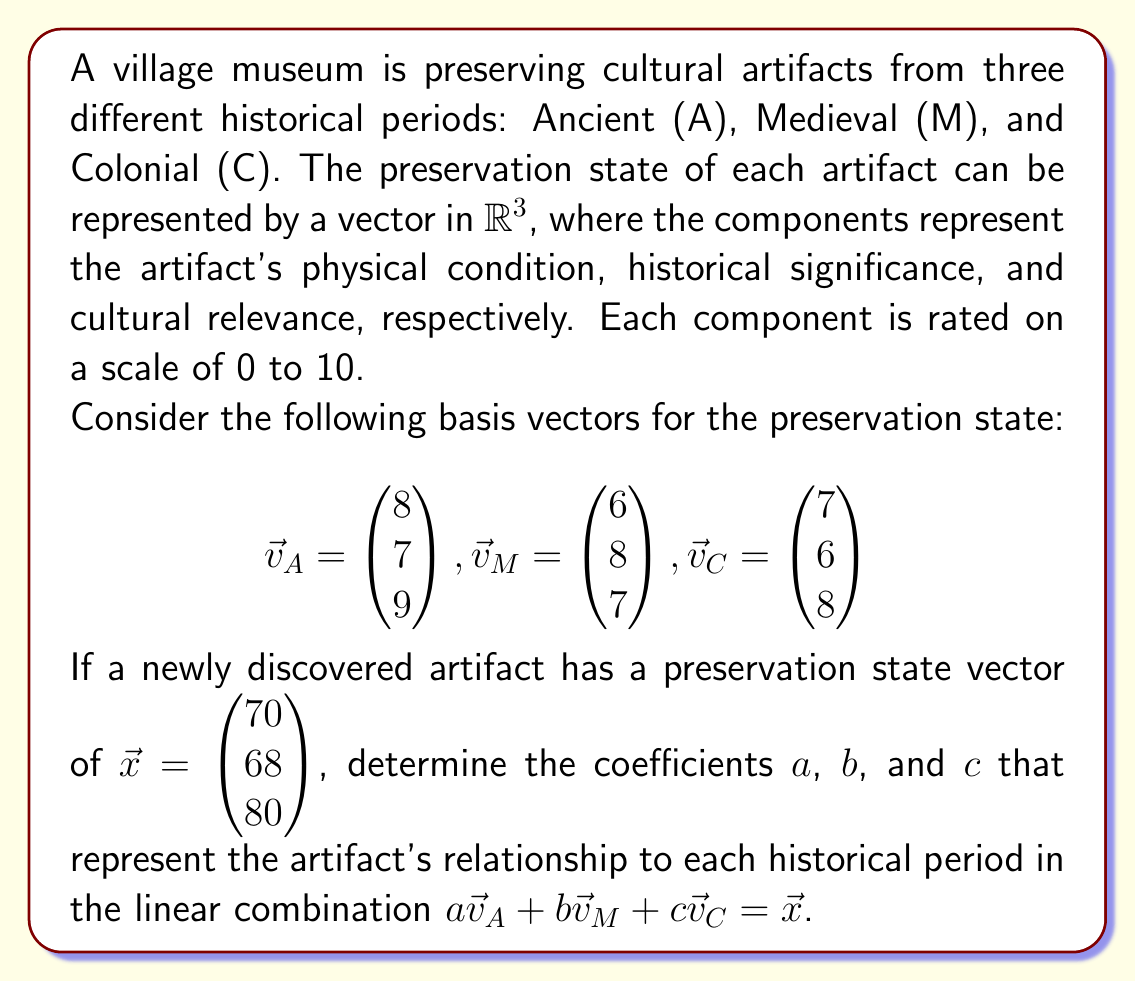Can you answer this question? To solve this problem, we need to use the concept of linear combinations and solving systems of linear equations. Let's approach this step-by-step:

1) We are given that $a\vec{v}_A + b\vec{v}_M + c\vec{v}_C = \vec{x}$. Let's expand this equation:

   $$ a\begin{pmatrix} 8 \\ 7 \\ 9 \end{pmatrix} + b\begin{pmatrix} 6 \\ 8 \\ 7 \end{pmatrix} + c\begin{pmatrix} 7 \\ 6 \\ 8 \end{pmatrix} = \begin{pmatrix} 70 \\ 68 \\ 80 \end{pmatrix} $$

2) This gives us a system of three linear equations:

   $$ 8a + 6b + 7c = 70 $$
   $$ 7a + 8b + 6c = 68 $$
   $$ 9a + 7b + 8c = 80 $$

3) We can solve this system using various methods. Let's use the elimination method:

4) Multiply the first equation by 7 and the second by -8:

   $$ 56a + 42b + 49c = 490 $$
   $$ -56a - 64b - 48c = -544 $$

5) Add these equations:

   $$ -22b + c = -54 $$

6) Multiply the second equation by 9 and the third by -7:

   $$ 63a + 72b + 54c = 612 $$
   $$ -63a - 49b - 56c = -560 $$

7) Add these equations:

   $$ 23b - 2c = 52 $$

8) Now we have two equations with two unknowns:

   $$ -22b + c = -54 $$
   $$ 23b - 2c = 52 $$

9) Multiply the first equation by 2 and add to the second:

   $$ -21b = -56 $$
   $$ b = \frac{56}{21} = \frac{8}{3} $$

10) Substitute this value of $b$ back into $-22b + c = -54$:

    $$ -22(\frac{8}{3}) + c = -54 $$
    $$ -\frac{176}{3} + c = -54 $$
    $$ c = -54 + \frac{176}{3} = \frac{10}{3} $$

11) Now that we have $b$ and $c$, we can find $a$ using any of the original equations. Let's use the first one:

    $$ 8a + 6(\frac{8}{3}) + 7(\frac{10}{3}) = 70 $$
    $$ 8a + 16 + \frac{70}{3} = 70 $$
    $$ 8a = 70 - 16 - \frac{70}{3} = \frac{124}{3} $$
    $$ a = \frac{124}{24} = \frac{31}{6} $$

Therefore, the coefficients are $a = \frac{31}{6}$, $b = \frac{8}{3}$, and $c = \frac{10}{3}$.
Answer: $a = \frac{31}{6}$, $b = \frac{8}{3}$, $c = \frac{10}{3}$ 